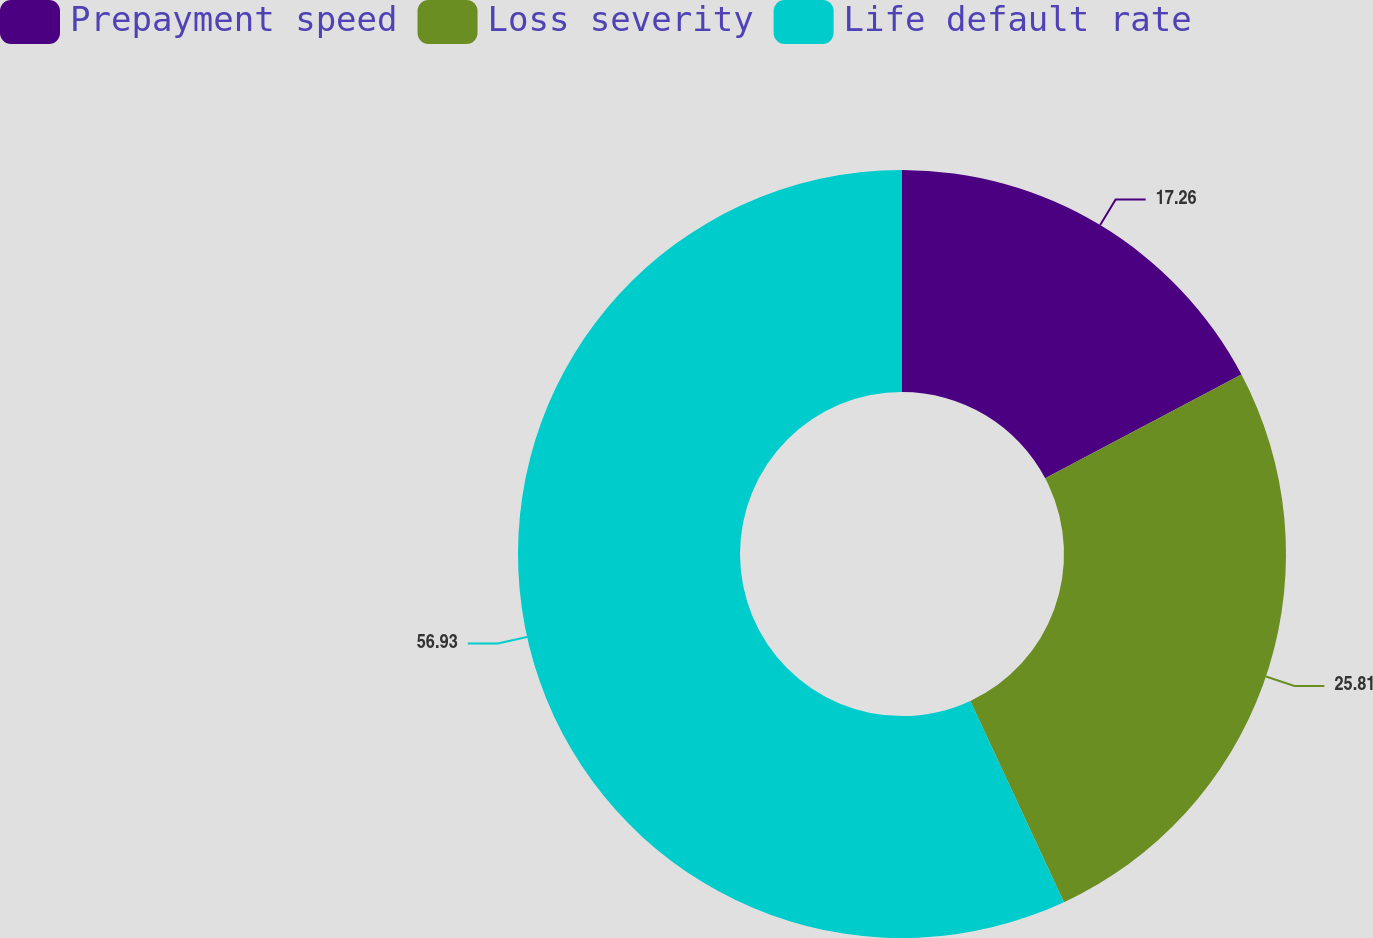<chart> <loc_0><loc_0><loc_500><loc_500><pie_chart><fcel>Prepayment speed<fcel>Loss severity<fcel>Life default rate<nl><fcel>17.26%<fcel>25.81%<fcel>56.93%<nl></chart> 